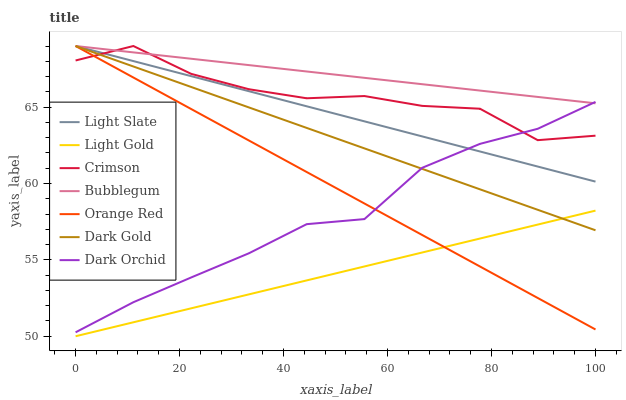Does Light Gold have the minimum area under the curve?
Answer yes or no. Yes. Does Bubblegum have the maximum area under the curve?
Answer yes or no. Yes. Does Light Slate have the minimum area under the curve?
Answer yes or no. No. Does Light Slate have the maximum area under the curve?
Answer yes or no. No. Is Light Slate the smoothest?
Answer yes or no. Yes. Is Crimson the roughest?
Answer yes or no. Yes. Is Bubblegum the smoothest?
Answer yes or no. No. Is Bubblegum the roughest?
Answer yes or no. No. Does Light Gold have the lowest value?
Answer yes or no. Yes. Does Light Slate have the lowest value?
Answer yes or no. No. Does Orange Red have the highest value?
Answer yes or no. Yes. Does Dark Orchid have the highest value?
Answer yes or no. No. Is Light Gold less than Dark Orchid?
Answer yes or no. Yes. Is Light Slate greater than Light Gold?
Answer yes or no. Yes. Does Dark Orchid intersect Dark Gold?
Answer yes or no. Yes. Is Dark Orchid less than Dark Gold?
Answer yes or no. No. Is Dark Orchid greater than Dark Gold?
Answer yes or no. No. Does Light Gold intersect Dark Orchid?
Answer yes or no. No. 